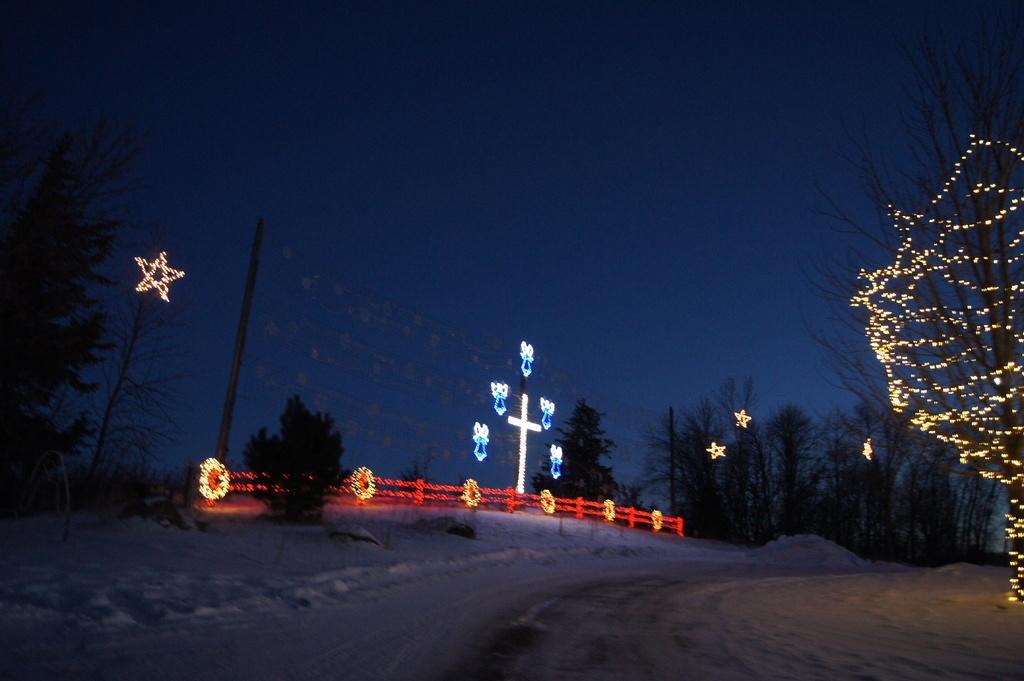In one or two sentences, can you explain what this image depicts? In this image we can see trees with stars, one tree with lights, some bushes, some grass, cross with lights, two poles with some decorative items, one Christmas tree, on fence decorated with red and gold decorative lights. So much of snow on the surface and at the top there is the sky. 